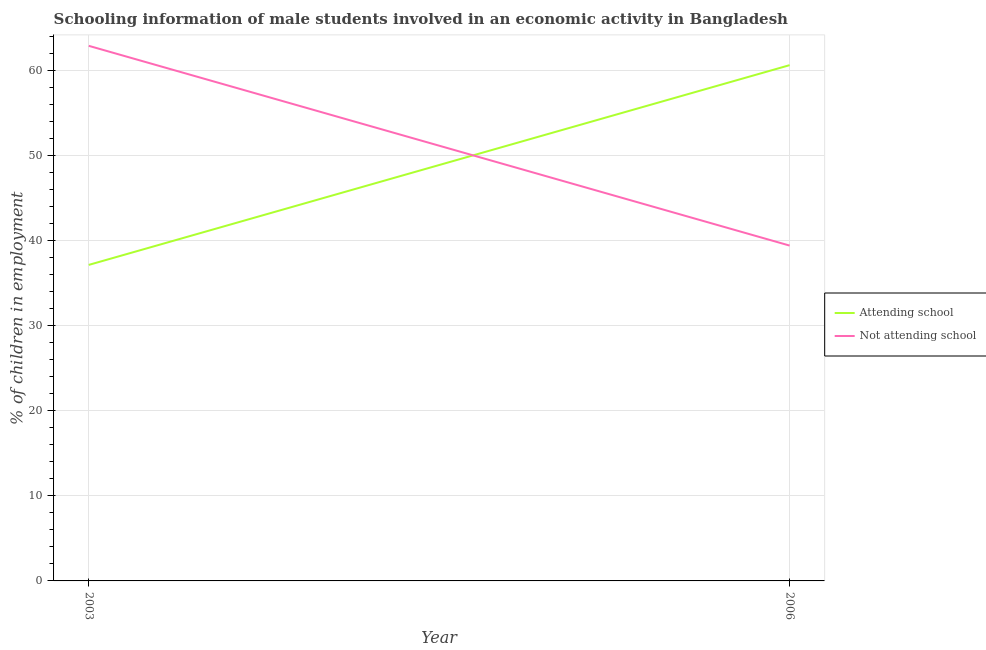Does the line corresponding to percentage of employed males who are not attending school intersect with the line corresponding to percentage of employed males who are attending school?
Keep it short and to the point. Yes. What is the percentage of employed males who are not attending school in 2006?
Your response must be concise. 39.4. Across all years, what is the maximum percentage of employed males who are not attending school?
Your answer should be compact. 62.87. Across all years, what is the minimum percentage of employed males who are not attending school?
Offer a very short reply. 39.4. In which year was the percentage of employed males who are not attending school minimum?
Your answer should be very brief. 2006. What is the total percentage of employed males who are attending school in the graph?
Provide a succinct answer. 97.73. What is the difference between the percentage of employed males who are not attending school in 2003 and that in 2006?
Keep it short and to the point. 23.47. What is the difference between the percentage of employed males who are attending school in 2006 and the percentage of employed males who are not attending school in 2003?
Your response must be concise. -2.27. What is the average percentage of employed males who are attending school per year?
Provide a short and direct response. 48.86. In the year 2006, what is the difference between the percentage of employed males who are not attending school and percentage of employed males who are attending school?
Give a very brief answer. -21.2. What is the ratio of the percentage of employed males who are attending school in 2003 to that in 2006?
Give a very brief answer. 0.61. Is the percentage of employed males who are attending school in 2003 less than that in 2006?
Keep it short and to the point. Yes. In how many years, is the percentage of employed males who are attending school greater than the average percentage of employed males who are attending school taken over all years?
Provide a succinct answer. 1. Is the percentage of employed males who are not attending school strictly greater than the percentage of employed males who are attending school over the years?
Offer a terse response. No. How many lines are there?
Keep it short and to the point. 2. How many years are there in the graph?
Provide a succinct answer. 2. What is the difference between two consecutive major ticks on the Y-axis?
Make the answer very short. 10. Are the values on the major ticks of Y-axis written in scientific E-notation?
Give a very brief answer. No. Does the graph contain grids?
Provide a succinct answer. Yes. Where does the legend appear in the graph?
Give a very brief answer. Center right. How many legend labels are there?
Make the answer very short. 2. What is the title of the graph?
Provide a short and direct response. Schooling information of male students involved in an economic activity in Bangladesh. What is the label or title of the Y-axis?
Your answer should be very brief. % of children in employment. What is the % of children in employment in Attending school in 2003?
Give a very brief answer. 37.13. What is the % of children in employment of Not attending school in 2003?
Keep it short and to the point. 62.87. What is the % of children in employment in Attending school in 2006?
Ensure brevity in your answer.  60.6. What is the % of children in employment in Not attending school in 2006?
Your answer should be compact. 39.4. Across all years, what is the maximum % of children in employment of Attending school?
Give a very brief answer. 60.6. Across all years, what is the maximum % of children in employment of Not attending school?
Provide a short and direct response. 62.87. Across all years, what is the minimum % of children in employment in Attending school?
Offer a very short reply. 37.13. Across all years, what is the minimum % of children in employment of Not attending school?
Your answer should be very brief. 39.4. What is the total % of children in employment of Attending school in the graph?
Your answer should be very brief. 97.73. What is the total % of children in employment of Not attending school in the graph?
Keep it short and to the point. 102.27. What is the difference between the % of children in employment of Attending school in 2003 and that in 2006?
Ensure brevity in your answer.  -23.47. What is the difference between the % of children in employment of Not attending school in 2003 and that in 2006?
Provide a succinct answer. 23.47. What is the difference between the % of children in employment of Attending school in 2003 and the % of children in employment of Not attending school in 2006?
Provide a short and direct response. -2.27. What is the average % of children in employment of Attending school per year?
Offer a very short reply. 48.86. What is the average % of children in employment of Not attending school per year?
Your answer should be compact. 51.14. In the year 2003, what is the difference between the % of children in employment in Attending school and % of children in employment in Not attending school?
Your answer should be very brief. -25.74. In the year 2006, what is the difference between the % of children in employment of Attending school and % of children in employment of Not attending school?
Your response must be concise. 21.2. What is the ratio of the % of children in employment of Attending school in 2003 to that in 2006?
Your response must be concise. 0.61. What is the ratio of the % of children in employment of Not attending school in 2003 to that in 2006?
Your answer should be very brief. 1.6. What is the difference between the highest and the second highest % of children in employment in Attending school?
Give a very brief answer. 23.47. What is the difference between the highest and the second highest % of children in employment in Not attending school?
Provide a succinct answer. 23.47. What is the difference between the highest and the lowest % of children in employment in Attending school?
Ensure brevity in your answer.  23.47. What is the difference between the highest and the lowest % of children in employment in Not attending school?
Your response must be concise. 23.47. 